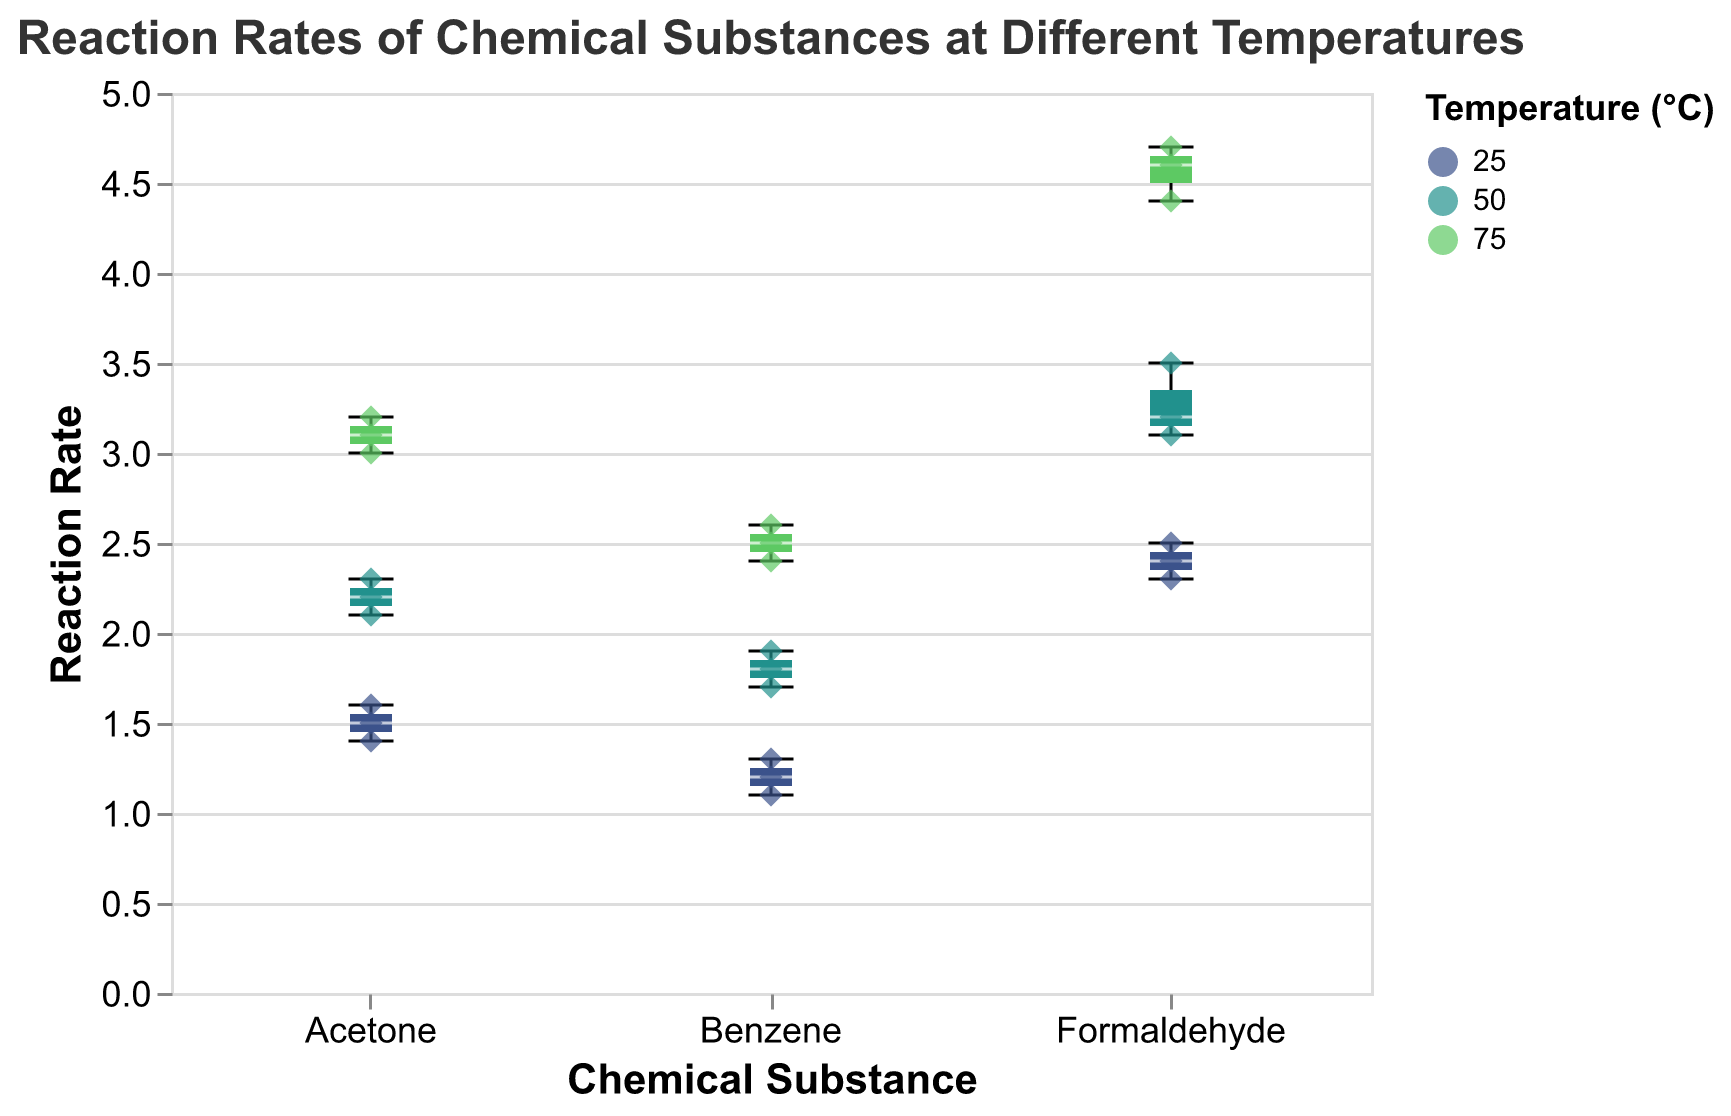What is the title of the figure? The title of the figure is usually displayed at the top and describes what the figure is about. Here, it states the subject of the plot.
Answer: Reaction Rates of Chemical Substances at Different Temperatures Which chemical substance shows the highest reaction rate? By examining the box plots and scatter points, you can observe the maximum points of each substance. Formaldehyde at 75°C has the highest reaction rate.
Answer: Formaldehyde How does the reaction rate of Benzene at 25°C compare to its rate at 50°C? Looking at Benzene’s reaction rates at different temperatures, it's clear that the rates are higher at 50°C compared to 25°C.
Answer: Higher at 50°C Which chemical substance has the most variability in reaction rate across all temperatures? Variability can be seen by the spread of the box plots for each substance. Formaldehyde has the widest spread, indicating the highest variability.
Answer: Formaldehyde What is the median reaction rate for Acetone at 75°C? The median value is indicated by the line inside the box for each temperature category. For Acetone at 75°C, identify the median line within the box plot.
Answer: 3.1 How do reaction rates of Formaldehyde at 25°C compare to Benzene at 75°C? By comparing the locations of the box plots and points for Formaldehyde at 25°C and Benzene at 75°C, Formaldehyde at 25°C has higher reaction rates.
Answer: Formaldehyde at 25°C Which chemical substance shows the least variability at 25°C? Find the box plot with the smallest range (interquartile range) at 25°C. Benzene has the smallest spread at 25°C.
Answer: Benzene What temperature results in the highest overall reaction rate for each chemical substance? Examine each substance individually and record the highest value of their reaction rate across temperatures. 75°C results in the highest rates for each substance.
Answer: 75°C for all substances How does the spread of reaction rates for Formaldehyde at 50°C compare to Acetone at 50°C? The spread is indicated by the range of the box plot. Formaldehyde at 50°C has a broader spread compared to Acetone at 50°C.
Answer: Formaldehyde has a broader spread Which temperature causes the reaction rate of Benzene to double compared to 25°C? Examine the reaction rates at 25°C and identify which higher temperature has approximately double the average rate. At 75°C, the reaction rate roughly doubles compared to 25°C.
Answer: 75°C What is the interquartile range (IQR) of reaction rates for Formaldehyde at 75°C? The IQR is the difference between the upper and lower quartiles of the box plot. The range for Formaldehyde at 75°C can be seen from the box plot.
Answer: 4.6 - 4.4 = 0.2 